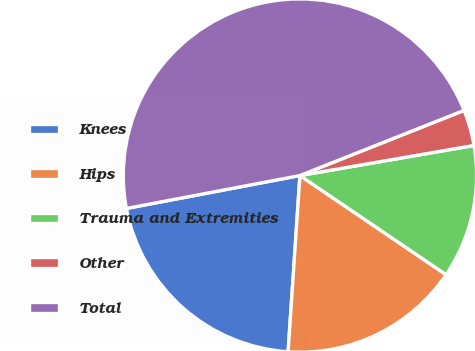<chart> <loc_0><loc_0><loc_500><loc_500><pie_chart><fcel>Knees<fcel>Hips<fcel>Trauma and Extremities<fcel>Other<fcel>Total<nl><fcel>20.95%<fcel>16.58%<fcel>12.21%<fcel>3.29%<fcel>46.97%<nl></chart> 